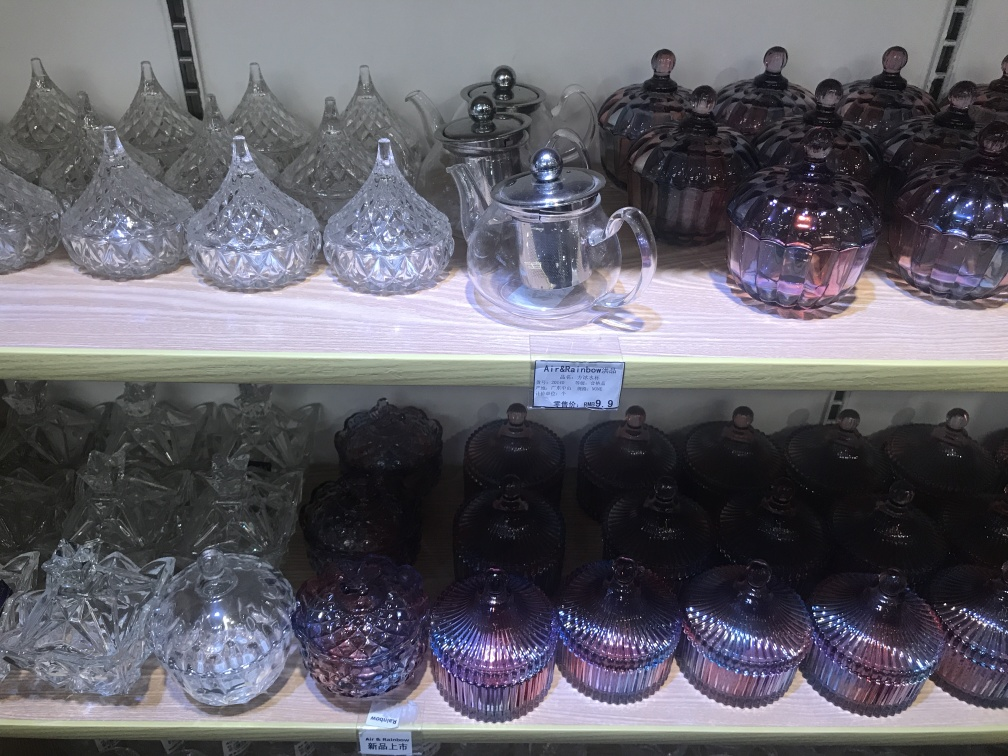How would you describe the color variation in this collection? This collection displays a diverse palette with clear, purple, and dark-toned glassware that presents an interesting range of options for buyers. The clear pieces exude a classic, timeless look, while the purple pieces add a vibrant touch. The dark-toned items are elegant and likely to blend well in modern decor settings. Which of these would be best for a contemporary kitchen setting? For a contemporary kitchen, the dark-toned glassware would be an excellent choice. Their sleek and modern appearance would complement the clean lines and minimalistic aesthetics that are often prevalent in modern kitchen designs. 